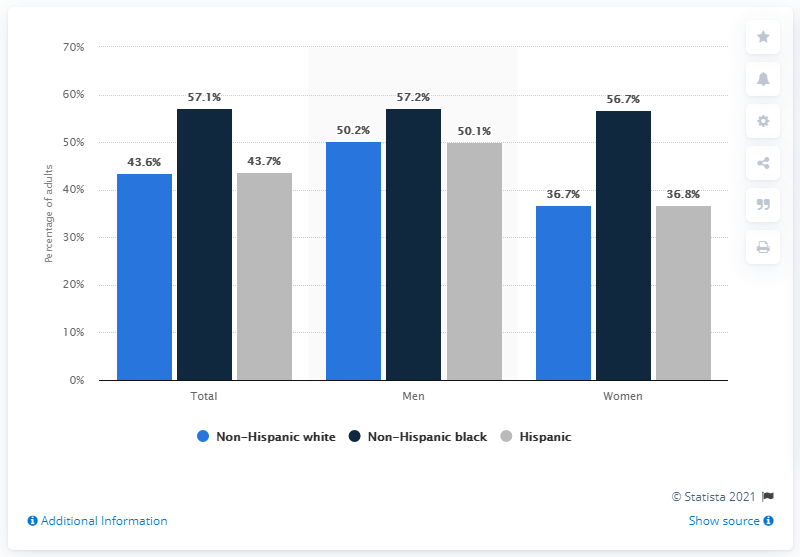Give some essential details in this illustration. During the period of 2017 to 2018, approximately 50.2% of non-Hispanic white males suffered from hypertension. 